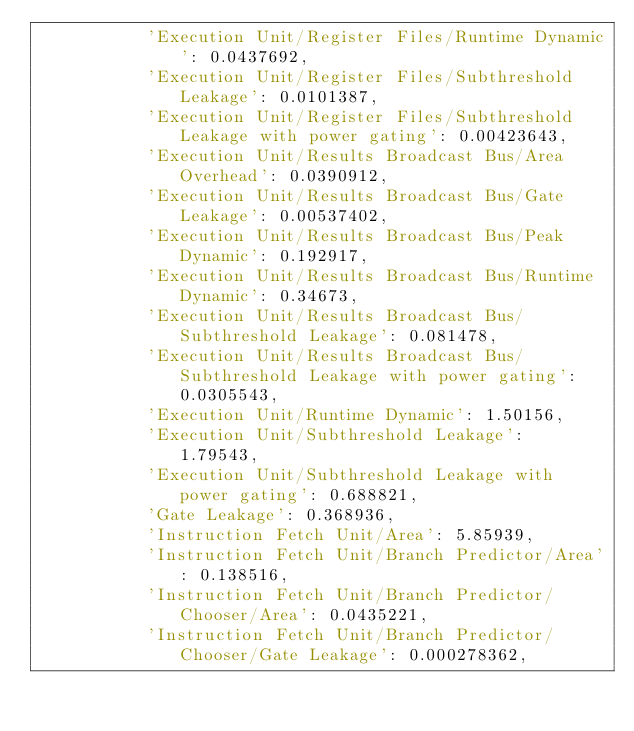<code> <loc_0><loc_0><loc_500><loc_500><_Python_>           'Execution Unit/Register Files/Runtime Dynamic': 0.0437692,
           'Execution Unit/Register Files/Subthreshold Leakage': 0.0101387,
           'Execution Unit/Register Files/Subthreshold Leakage with power gating': 0.00423643,
           'Execution Unit/Results Broadcast Bus/Area Overhead': 0.0390912,
           'Execution Unit/Results Broadcast Bus/Gate Leakage': 0.00537402,
           'Execution Unit/Results Broadcast Bus/Peak Dynamic': 0.192917,
           'Execution Unit/Results Broadcast Bus/Runtime Dynamic': 0.34673,
           'Execution Unit/Results Broadcast Bus/Subthreshold Leakage': 0.081478,
           'Execution Unit/Results Broadcast Bus/Subthreshold Leakage with power gating': 0.0305543,
           'Execution Unit/Runtime Dynamic': 1.50156,
           'Execution Unit/Subthreshold Leakage': 1.79543,
           'Execution Unit/Subthreshold Leakage with power gating': 0.688821,
           'Gate Leakage': 0.368936,
           'Instruction Fetch Unit/Area': 5.85939,
           'Instruction Fetch Unit/Branch Predictor/Area': 0.138516,
           'Instruction Fetch Unit/Branch Predictor/Chooser/Area': 0.0435221,
           'Instruction Fetch Unit/Branch Predictor/Chooser/Gate Leakage': 0.000278362,</code> 